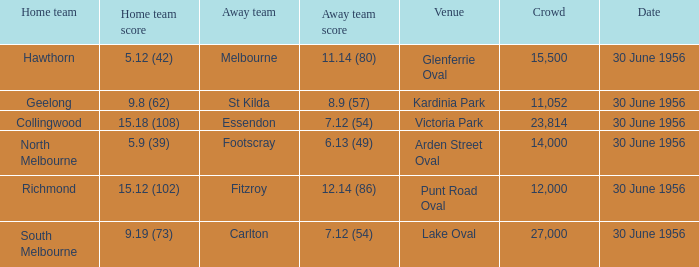What is the home team at Victoria Park with an Away team score of 7.12 (54) and more than 12,000 people? Collingwood. 